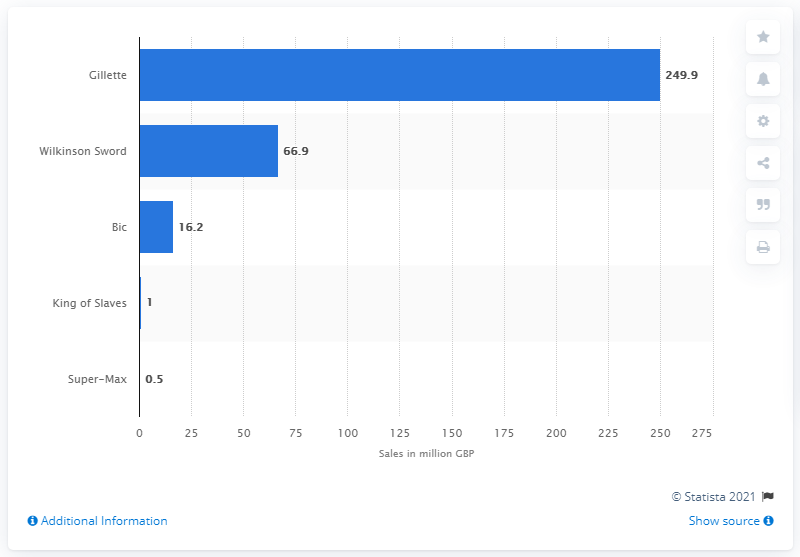Draw attention to some important aspects in this diagram. Gillette ranked the highest among the men's blades brands sold in the UK. 